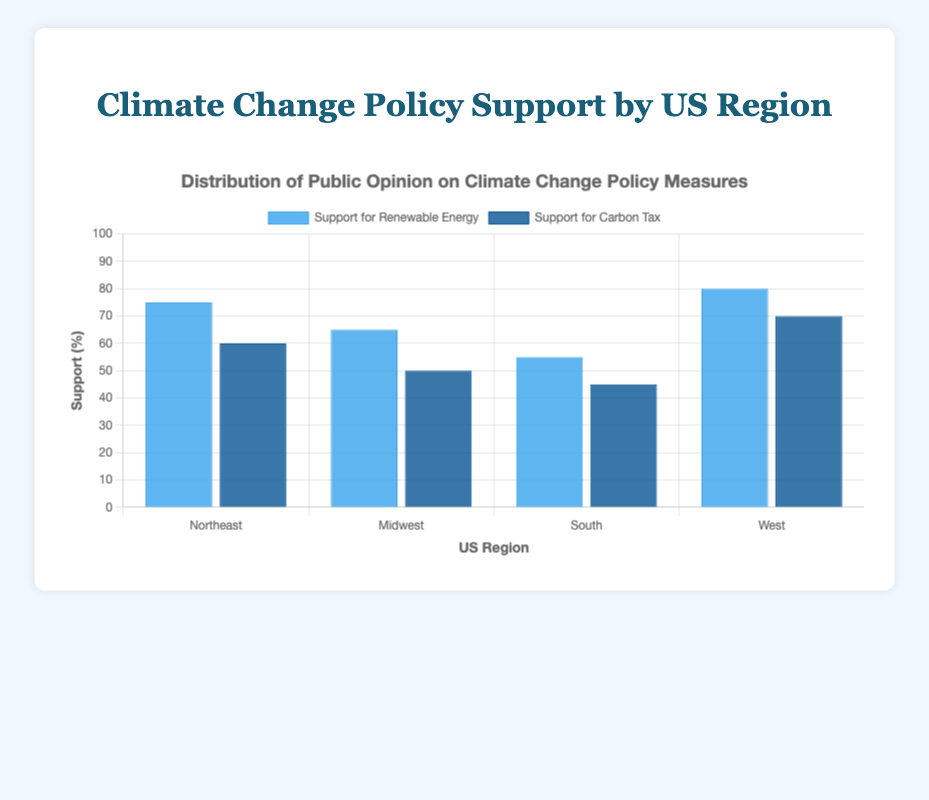Which region has the highest support for renewable energy? By looking at the height of the blue bars, the West region has the tallest bar for renewable energy support.
Answer: West Which region has the least support for a carbon tax? The shortest dark blue bar represents the region with the least support for a carbon tax, which is the South.
Answer: South How much higher is the support for renewable energy compared to the carbon tax in the Northeast? In the Northeast, support for renewable energy is 75%, while support for the carbon tax is 60%. The difference is 75% - 60% = 15%.
Answer: 15% What is the average support for renewable energy across all regions? Adding the support percentages for renewable energy: 75% (Northeast) + 65% (Midwest) + 55% (South) + 80% (West) = 275%. The average is 275% / 4 = 68.75%.
Answer: 68.75% Compare the support for renewable energy between the West and the South. How much higher is it in the West? Support for renewable energy is 80% in the West and 55% in the South. The difference is 80% - 55% = 25%.
Answer: 25% Which region has a smaller difference between support for renewable energy and a carbon tax: the Midwest or the South? In the Midwest, the difference is 65% - 50% = 15%. In the South, it is 55% - 45% = 10%. The South has a smaller difference.
Answer: South Rank the regions based on their support for carbon tax from highest to lowest. By comparing the heights of the dark blue bars: West (70%), Northeast (60%), Midwest (50%), South (45%).
Answer: West, Northeast, Midwest, South What is the combined percentage of support for renewable energy in the Northeast and Midwest? The support for renewable energy in the Northeast is 75% and in the Midwest is 65%. Their combined support is 75% + 65% = 140%.
Answer: 140% Find the region with the smallest difference between support for both policy measures. By calculating the differences: Northeast is 15%, Midwest is 15%, South is 10%, West is 10%. The South and West have the smallest differences, tied at 10%.
Answer: South and West Which region shows a larger visual gap in support between the two policy measures, the Northeast or the West? The visual gap between the blue and dark blue bars in the Northeast is 15%, while in the West, it is 10%. The larger gap is in the Northeast.
Answer: Northeast 